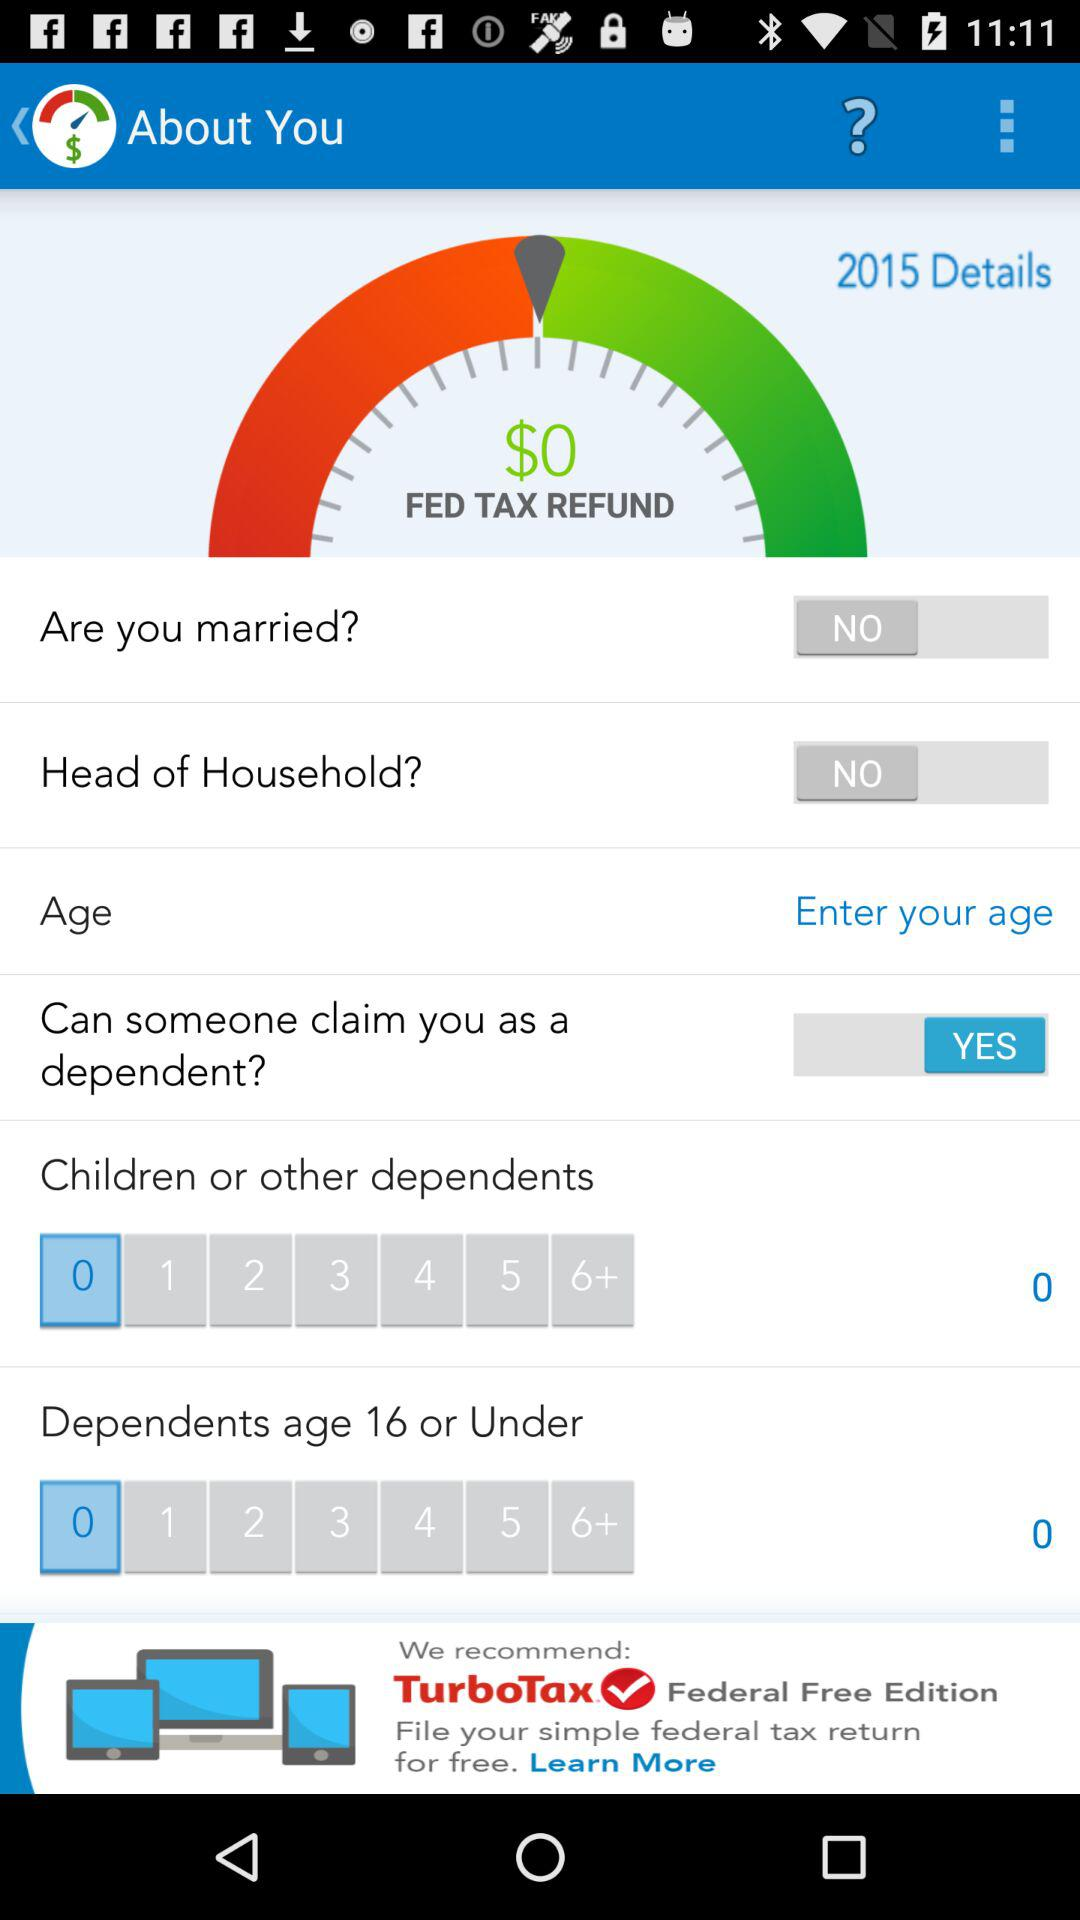What is the count of children or other dependents? The count is 0. 